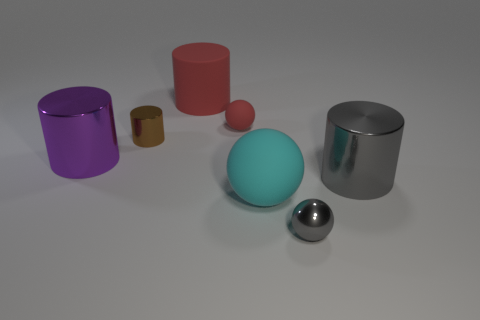Subtract all purple cylinders. How many cylinders are left? 3 Subtract all matte balls. How many balls are left? 1 Add 1 big purple cylinders. How many objects exist? 8 Subtract 2 cylinders. How many cylinders are left? 2 Subtract all blue cylinders. Subtract all cyan spheres. How many cylinders are left? 4 Subtract all cylinders. How many objects are left? 3 Subtract all big rubber cylinders. Subtract all metallic cylinders. How many objects are left? 3 Add 1 small brown metal things. How many small brown metal things are left? 2 Add 1 tiny red objects. How many tiny red objects exist? 2 Subtract 0 blue balls. How many objects are left? 7 